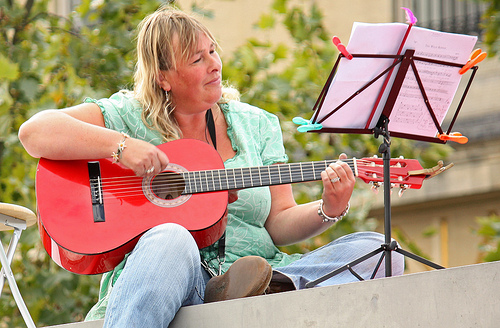<image>
Is the bracelet under the music stand? No. The bracelet is not positioned under the music stand. The vertical relationship between these objects is different. 